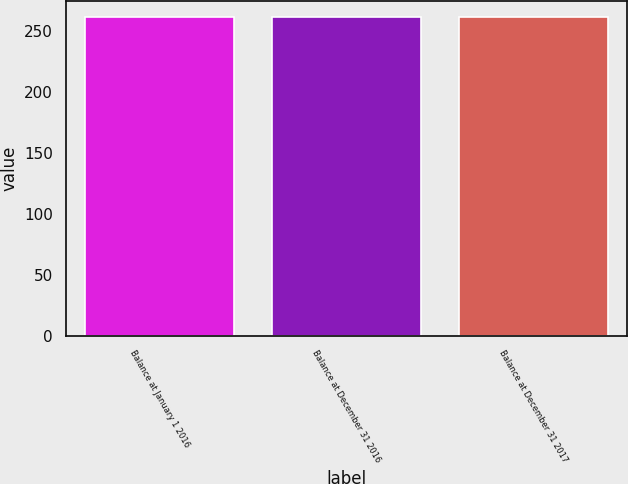<chart> <loc_0><loc_0><loc_500><loc_500><bar_chart><fcel>Balance at January 1 2016<fcel>Balance at December 31 2016<fcel>Balance at December 31 2017<nl><fcel>261<fcel>261.1<fcel>261.2<nl></chart> 